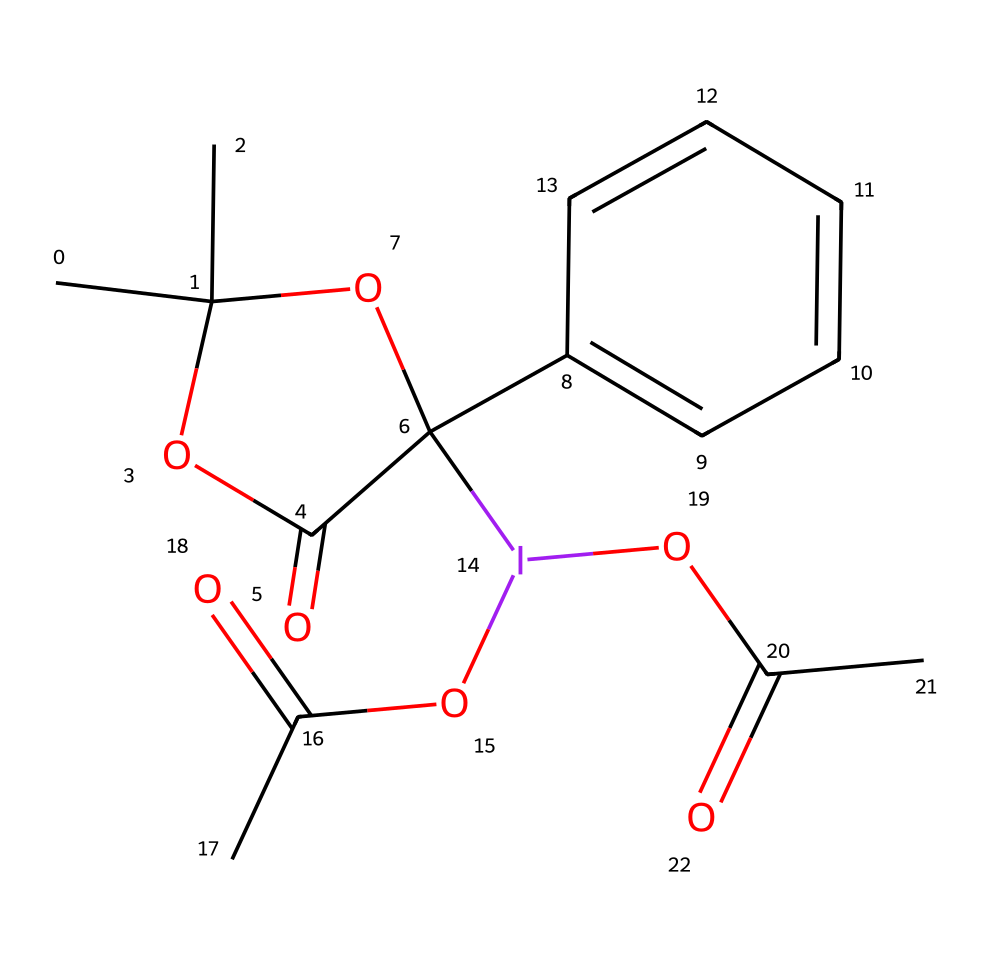How many carbon atoms are present in the structure? By inspecting the SMILES representation, we can count the number of carbon atoms denoted by 'C'. Each 'C' or '(C)' in the structure indicates a carbon atom. In this case, there are 14 carbon atoms in total.
Answer: 14 What is the oxidation state of iodine in this compound? To determine the oxidation state of iodine, we consider its bonding environment. Iodine is bonded to three oxygen atoms and a carbon atom, and since it typically has an oxidation state of +1 in hypervalent compounds, we assess its overall electron distribution. The oxidation state of iodine here is +3.
Answer: +3 What functional groups are present in Dess-Martin periodinane? Analyzing the SMILES structure, we can identify the functional groups by looking for specific patterns: carboxylic acid (-COOH) appears with 'OC(=O)', and ether (-O-) is present as well. There are two acyl groups also noted in the structure. Therefore, the main functional groups present are carboxylic acids and ethers.
Answer: carboxylic acids and ethers What type of reaction can Dess-Martin periodinane facilitate? Dess-Martin periodinane is a strong oxidizing agent due to the hypervalent nature of iodine. It typically participates in oxidation reactions, particularly converting alcohols to carbonyl compounds. Thus, the main type of reaction facilitated is oxidation.
Answer: oxidation How does hypervalency contribute to the reactivity of iodine in Dess-Martin periodinane? In hypervalent compounds, iodine can expand its valency, which allows it to engage with multiple ligands, including oxygen, enhancing its reactivity. This molecular configuration enables Dess-Martin periodinane to act effectively as an oxidizing agent, as it can stabilize the transition states during electron transfer.
Answer: enhances reactivity What is the role of the acyl groups in the reactivity of Dess-Martin periodinane? The acyl groups in Dess-Martin periodinane not only enhance the stability of the molecule but also facilitate the electron transfer required in oxidation reactions. Their presence helps in delocalizing charge and promotes reactivity, making the compound a powerful oxidizing agent.
Answer: facilitate oxidation 